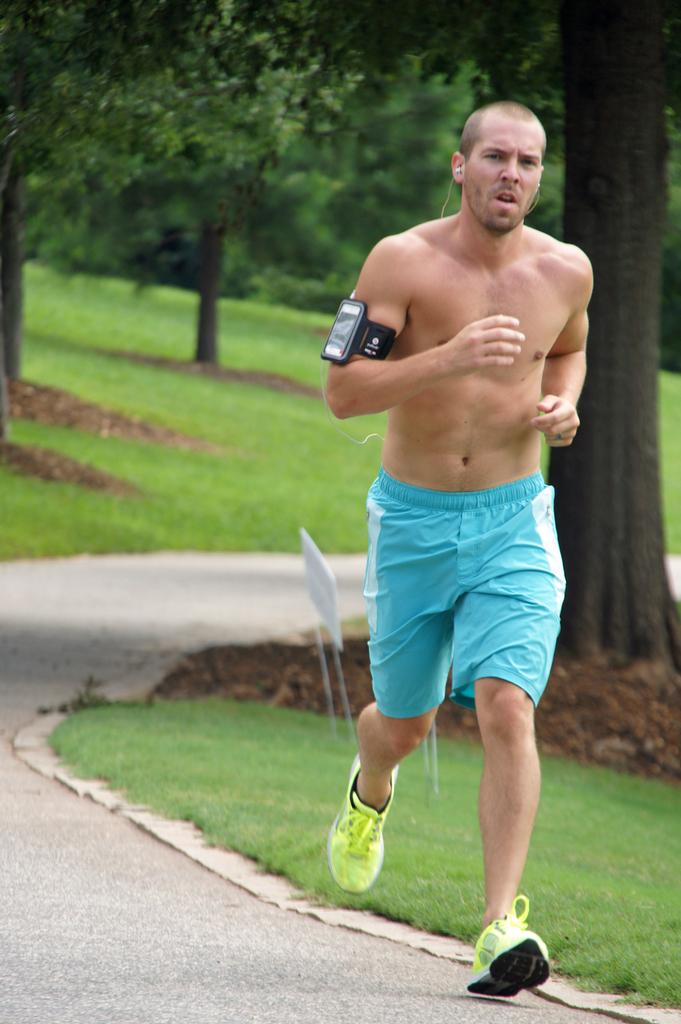Who is present in the image? There is a man in the image. What is the man wearing on his feet? The man is wearing shoes. What is the man doing in the image? The man is running on the road. Does the man have any electronic devices with him? Yes, the man has a mobile phone. What type of vegetation can be seen beside the road? There is grass beside the road. What can be seen in the distance in the image? There are trees in the background of the image. What type of sleet is falling on the man in the image? There is no sleet present in the image; it is a clear day with no precipitation. How many crows are perched on the trees in the background? There are no crows visible in the image; only trees can be seen in the background. 